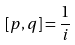Convert formula to latex. <formula><loc_0><loc_0><loc_500><loc_500>[ p , q ] = \frac { 1 } { i }</formula> 